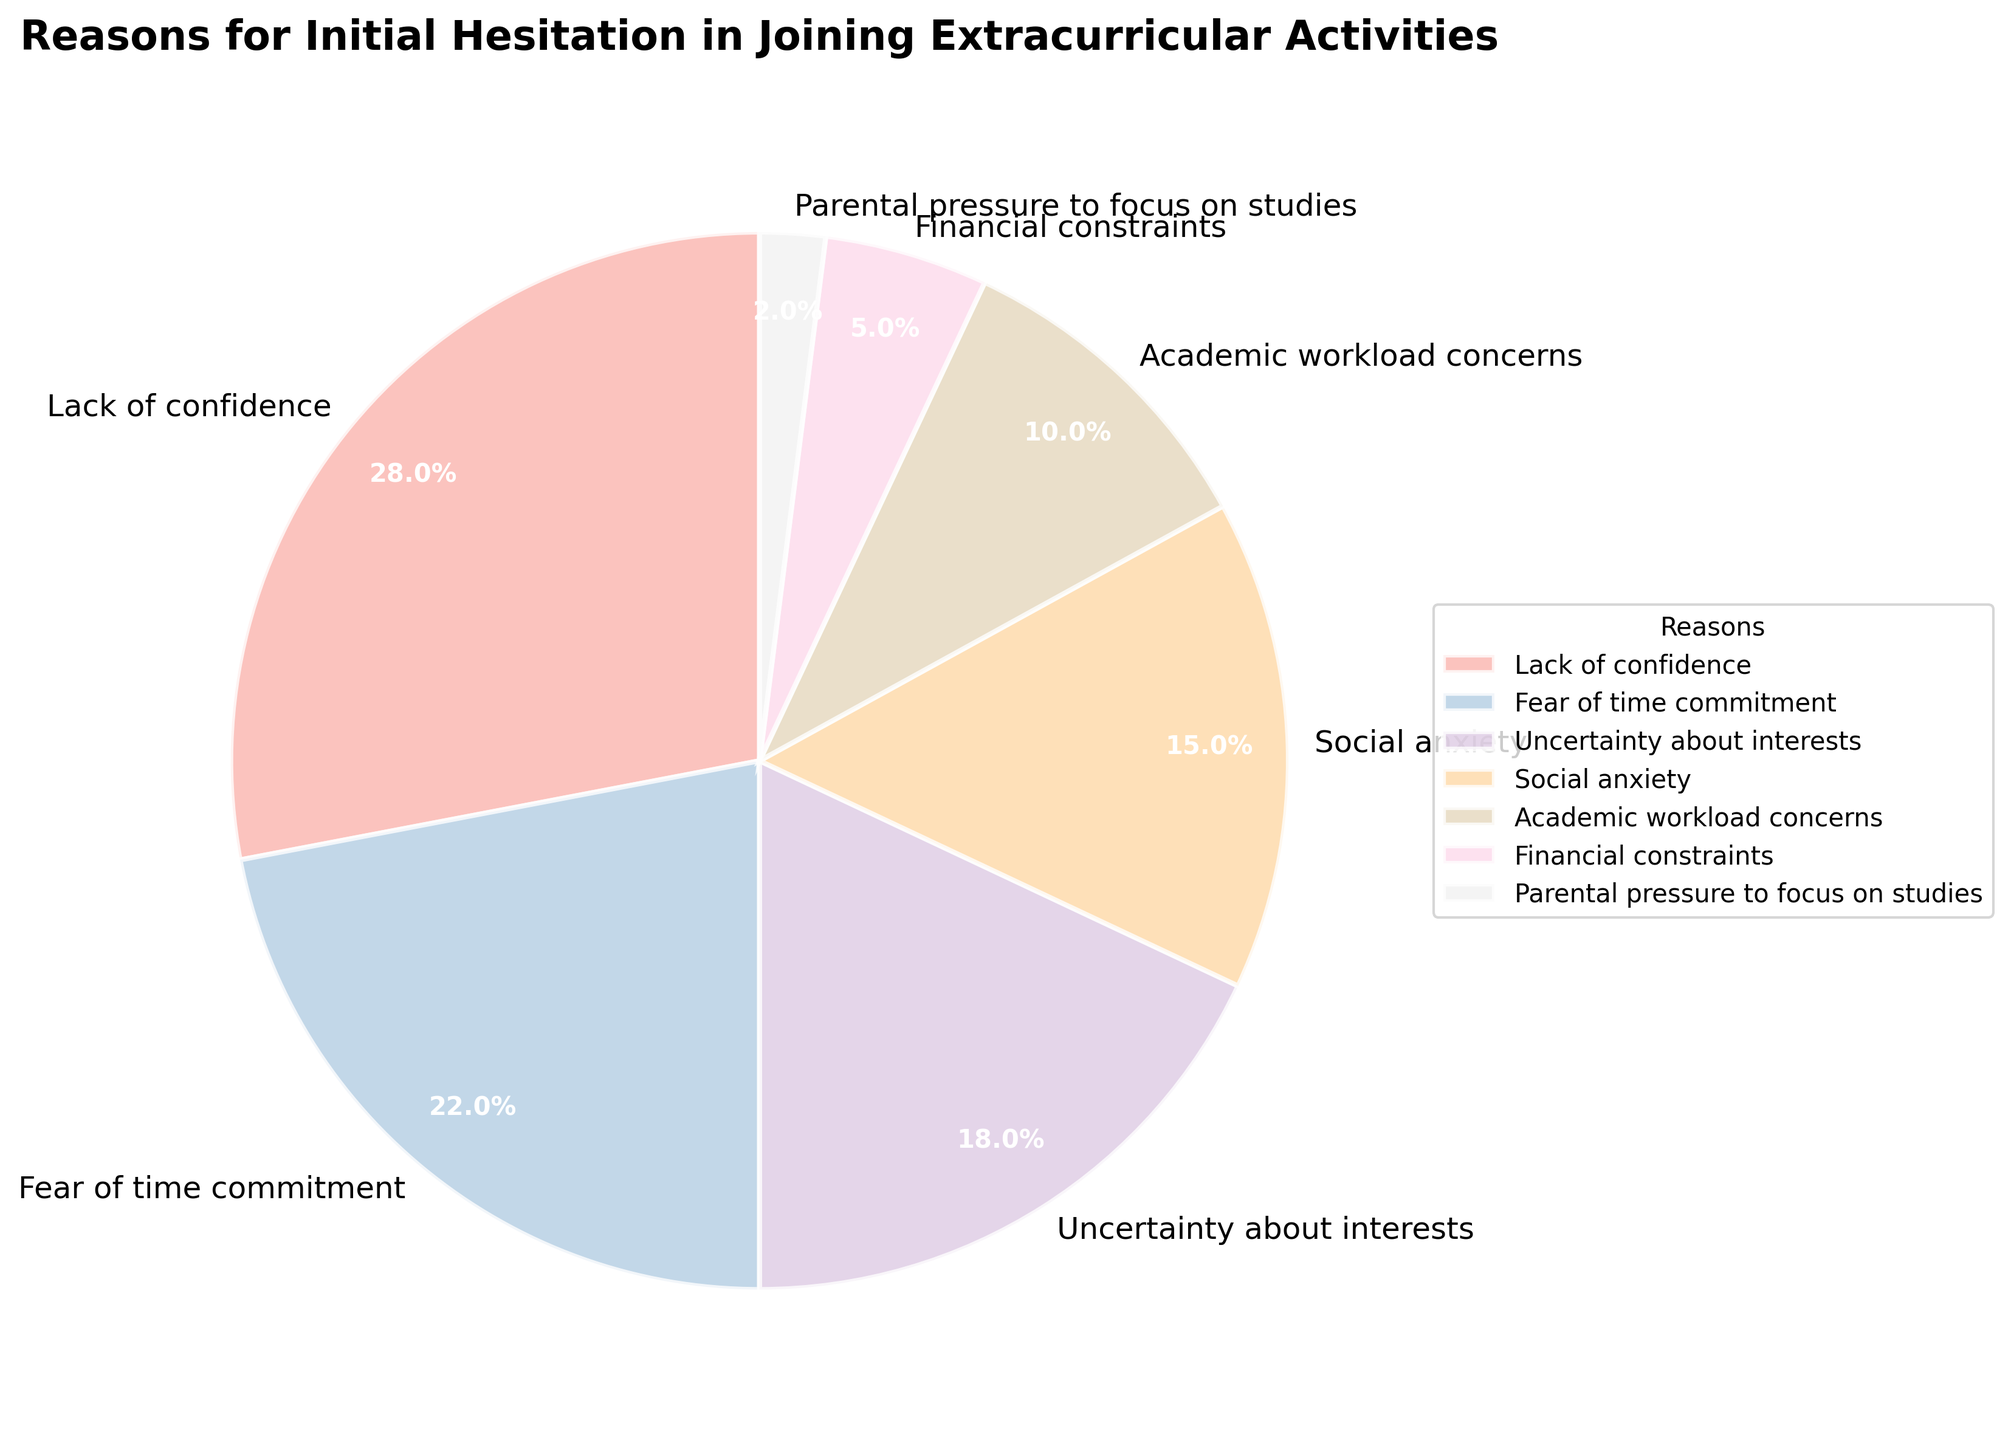What is the most common reason for initial hesitation in joining extracurricular activities? The figure shows various reasons for hesitation with their respective percentages. By identifying the reason with the highest percentage, we find that "Lack of confidence" stands out.
Answer: Lack of confidence Which two reasons have almost equal percentages, and what are they? By looking at the data in the figure, we can compare the percentages. Both "Uncertainty about interests" and "Social anxiety" have close percentages of 18% and 15%, respectively.
Answer: Uncertainty about interests and Social anxiety How much more significant is "Lack of confidence" compared to "Parental pressure to focus on studies"? To find the difference, subtract the percentage of "Parental pressure to focus on studies" from "Lack of confidence." This is 28% - 2% = 26%.
Answer: 26% Combine the percentages of "Fear of time commitment" and "Academic workload concerns" and express it as a percentage. Add the two percentages: 22% and 10%. The total is 22% + 10% = 32%.
Answer: 32% What percentage of reasons for hesitation are related to school or academics? "Academic workload concerns" (10%) and "Parental pressure to focus on studies" (2%) are both related to school/academics. Adding them, we get 10% + 2% = 12%.
Answer: 12% Which reason for hesitation is least common, and what is its percentage? The figure shows the smallest section, which corresponds to "Parental pressure to focus on studies" with 2%.
Answer: Parental pressure to focus on studies, 2% Rank "Fear of time commitment" and "Uncertainty about interests" by their percentages from highest to lowest. "Fear of time commitment" has a percentage of 22%, and "Uncertainty about interests" has 18%. Therefore, "Fear of time commitment" ranks higher than "Uncertainty about interests."
Answer: Fear of time commitment, Uncertainty about interests What is the combined percentage of reasons that are directly related to emotional or psychological concerns? "Lack of confidence" (28%), "Social anxiety" (15%), and partially "Uncertainty about interests" (18% can be considered a psychological concern) sum up to 28% + 15% + 18% = 61%.
Answer: 61% Which segment, represented by a pastel color, has the smallest wedge, and what does it represent? The smallest wedge in pastel colors represents "Parental pressure to focus on studies," indicating it has the smallest percentage (2%).
Answer: Parental pressure to focus on studies 